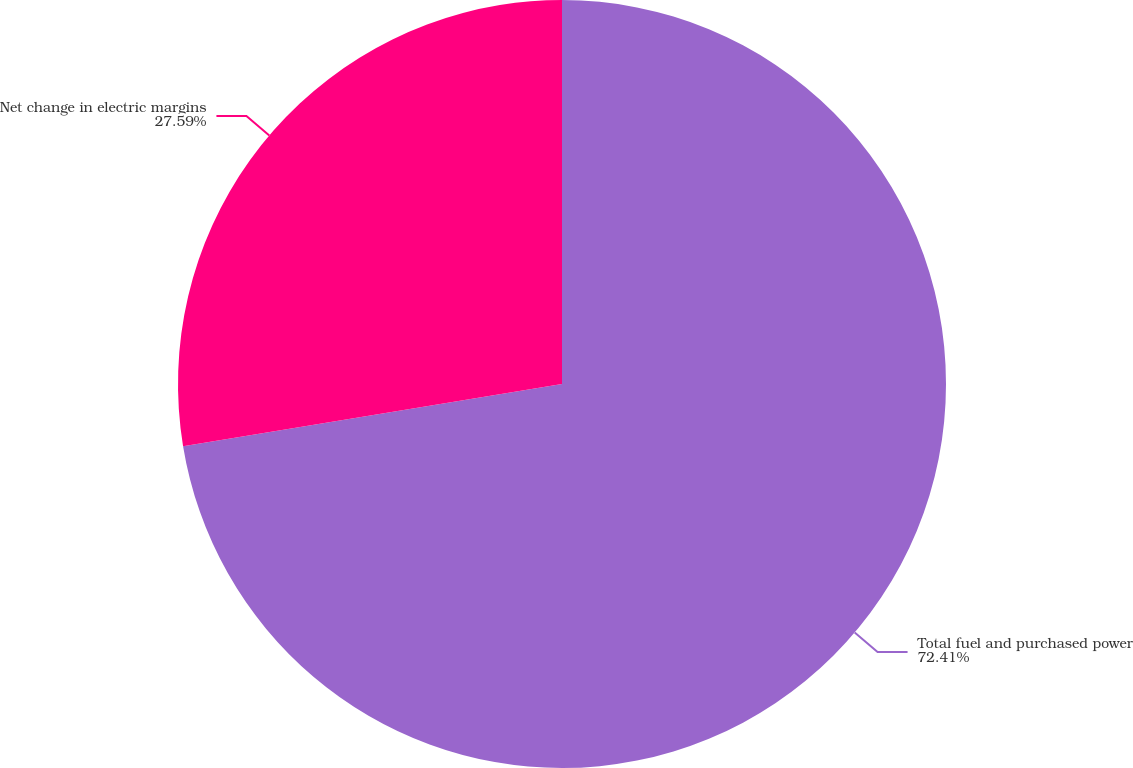Convert chart. <chart><loc_0><loc_0><loc_500><loc_500><pie_chart><fcel>Total fuel and purchased power<fcel>Net change in electric margins<nl><fcel>72.41%<fcel>27.59%<nl></chart> 